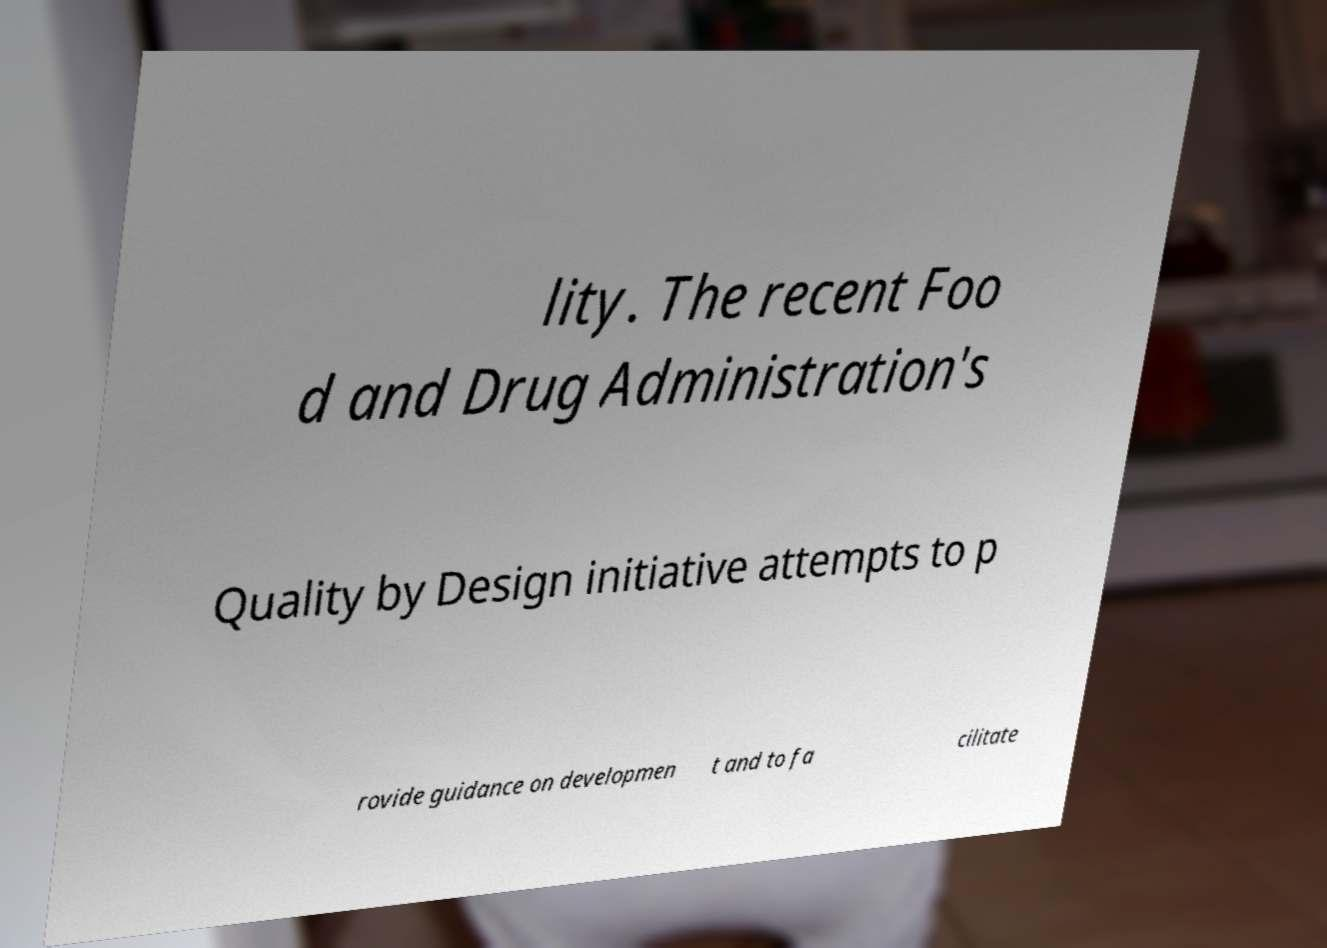Please identify and transcribe the text found in this image. lity. The recent Foo d and Drug Administration's Quality by Design initiative attempts to p rovide guidance on developmen t and to fa cilitate 